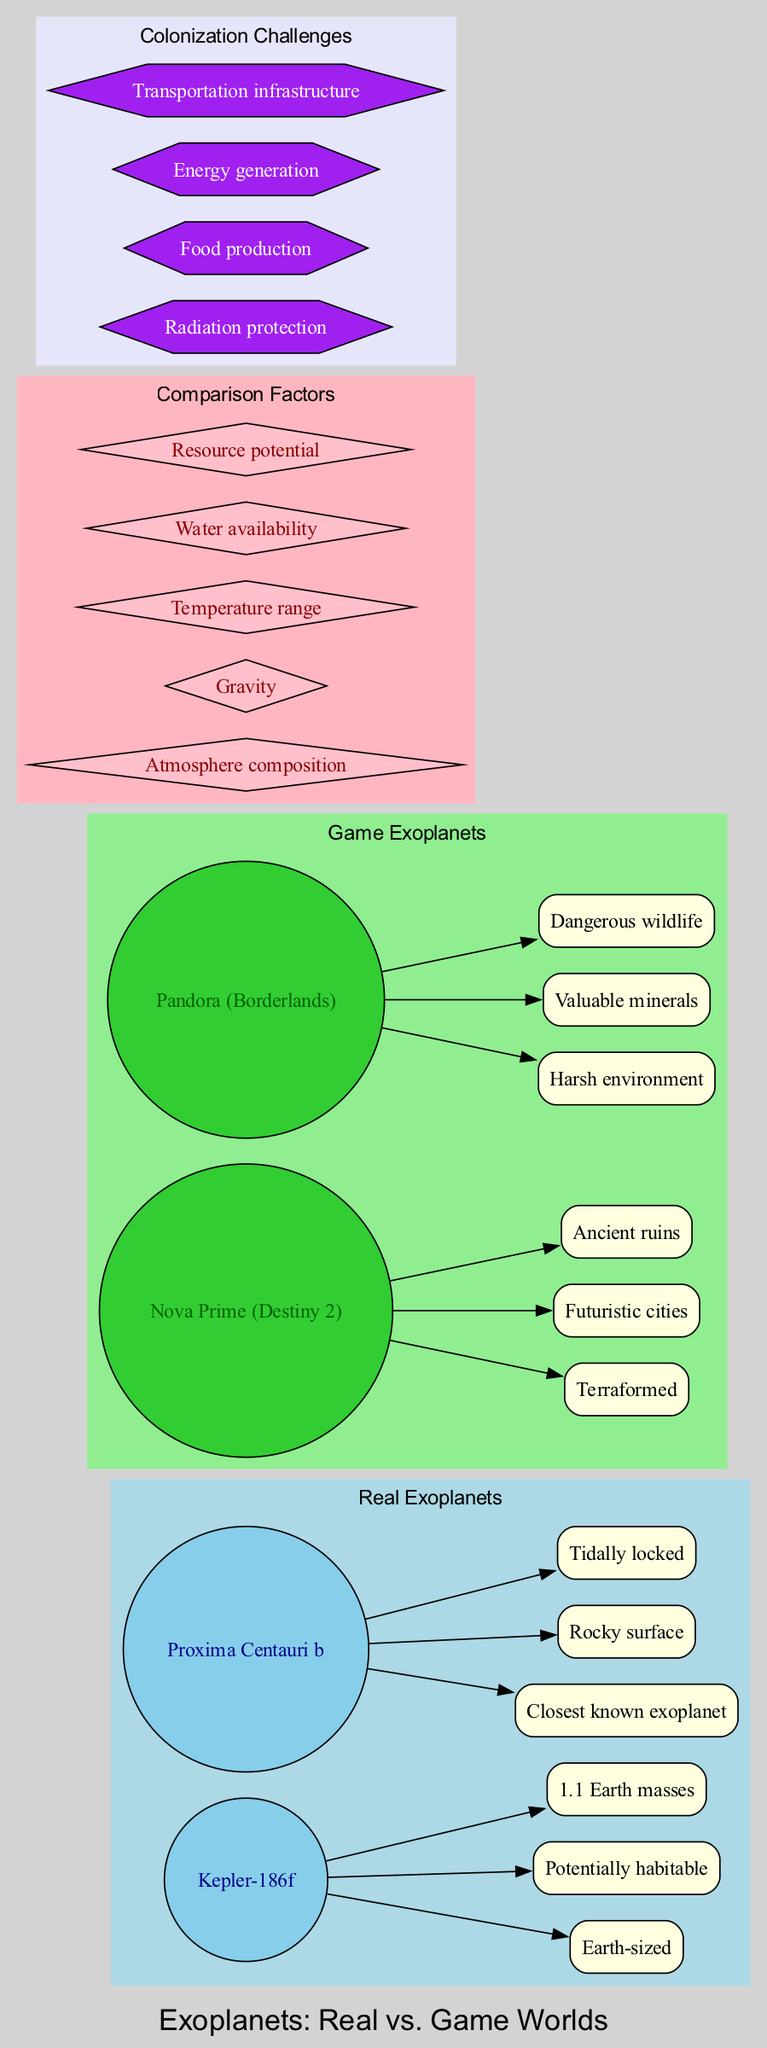What is the name of the closest known exoplanet? The diagram lists "Proxima Centauri b" as the closest known exoplanet under the section for Real Exoplanets.
Answer: Proxima Centauri b How many features are associated with Nova Prime? The diagram shows three features listed for Nova Prime in the Game Exoplanets section.
Answer: 3 What is the atmosphere composition factor? In the Comparison Factors section, "Atmosphere composition" is one of the factors listed.
Answer: Atmosphere composition Which exoplanet has a potentially habitable designation? The diagram indicates "Kepler-186f" under Real Exoplanets has the feature of being potentially habitable.
Answer: Kepler-186f What color represents the Game Exoplanets in the diagram? The diagram uses green shades, specifically limegreen for Game Exoplanets, which visually distinguishes it from Real Exoplanets and comparison factors.
Answer: Green Which challenge is associated with energy generation? The colonization challenges section lists "Energy generation" as one of the challenges.
Answer: Energy generation Which real exoplanet has 1.1 Earth masses? "Kepler-186f" is noted as having an Earth mass of 1.1 in the features section for Real Exoplanets.
Answer: Kepler-186f What type of environment does Pandora have? The diagram describes "Pandora" as having a Harsh environment listed under Game Exoplanets.
Answer: Harsh environment Which comparison factor is focused on resource supply? "Resource potential" is one of the comparison factors noted in the diagram, indicating it's about resource supply.
Answer: Resource potential 